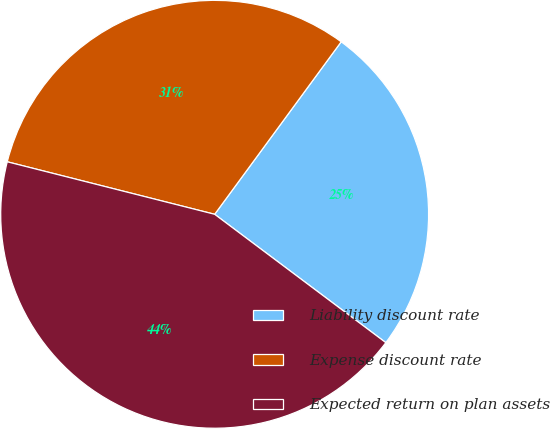Convert chart. <chart><loc_0><loc_0><loc_500><loc_500><pie_chart><fcel>Liability discount rate<fcel>Expense discount rate<fcel>Expected return on plan assets<nl><fcel>25.17%<fcel>31.13%<fcel>43.71%<nl></chart> 